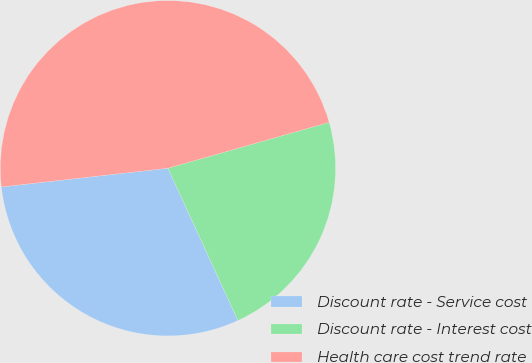Convert chart. <chart><loc_0><loc_0><loc_500><loc_500><pie_chart><fcel>Discount rate - Service cost<fcel>Discount rate - Interest cost<fcel>Health care cost trend rate<nl><fcel>30.08%<fcel>22.56%<fcel>47.37%<nl></chart> 